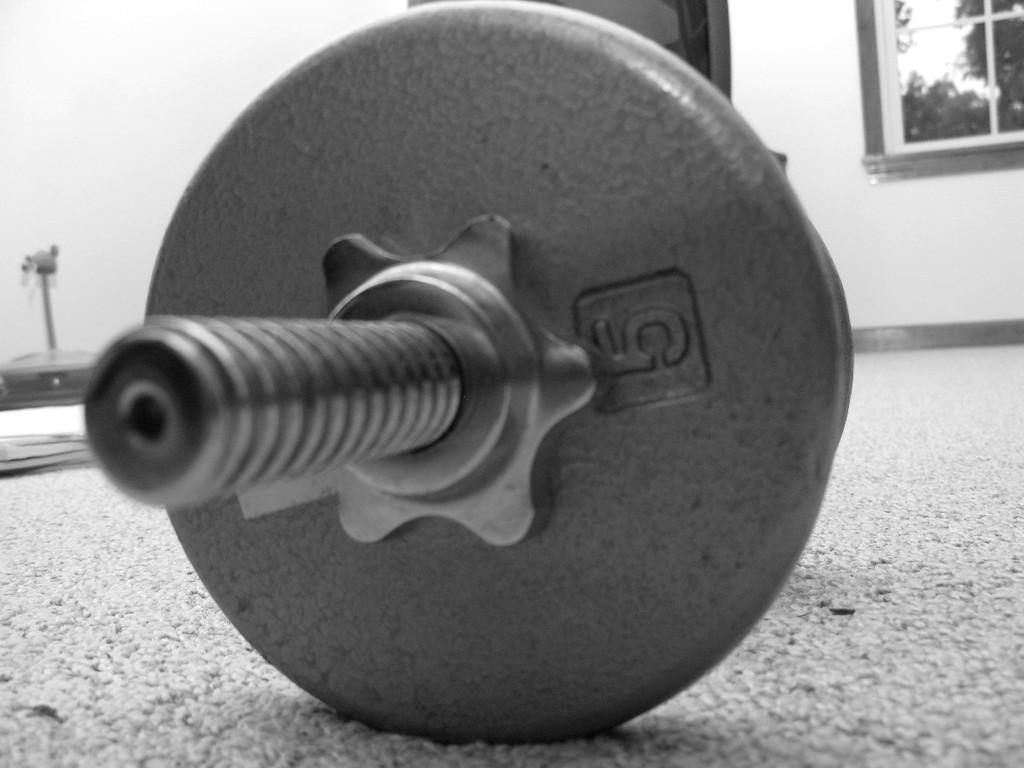What is the color scheme of the image? The image is black and white. What object with a number can be seen in the image? There is a nut with a number in the image. What architectural features are visible in the background of the image? There is a door and a window to a building in the background of the image. What type of surface is visible in the image? The surface is visible in the image. How many boats are docked at the harbor in the image? There is no harbor or boats present in the image. What type of balls are being juggled by the clown in the image? There is no clown or balls present in the image. 